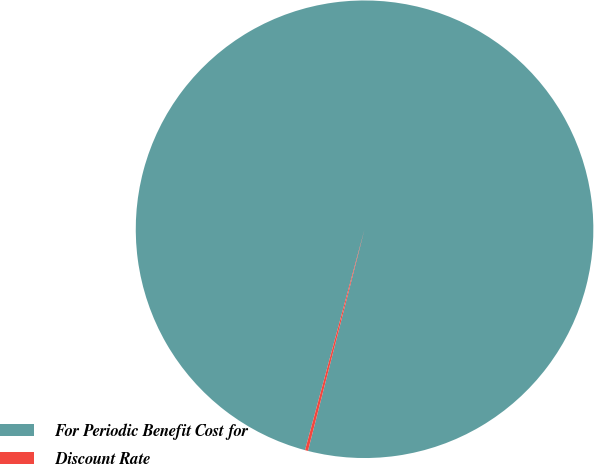<chart> <loc_0><loc_0><loc_500><loc_500><pie_chart><fcel>For Periodic Benefit Cost for<fcel>Discount Rate<nl><fcel>99.79%<fcel>0.21%<nl></chart> 